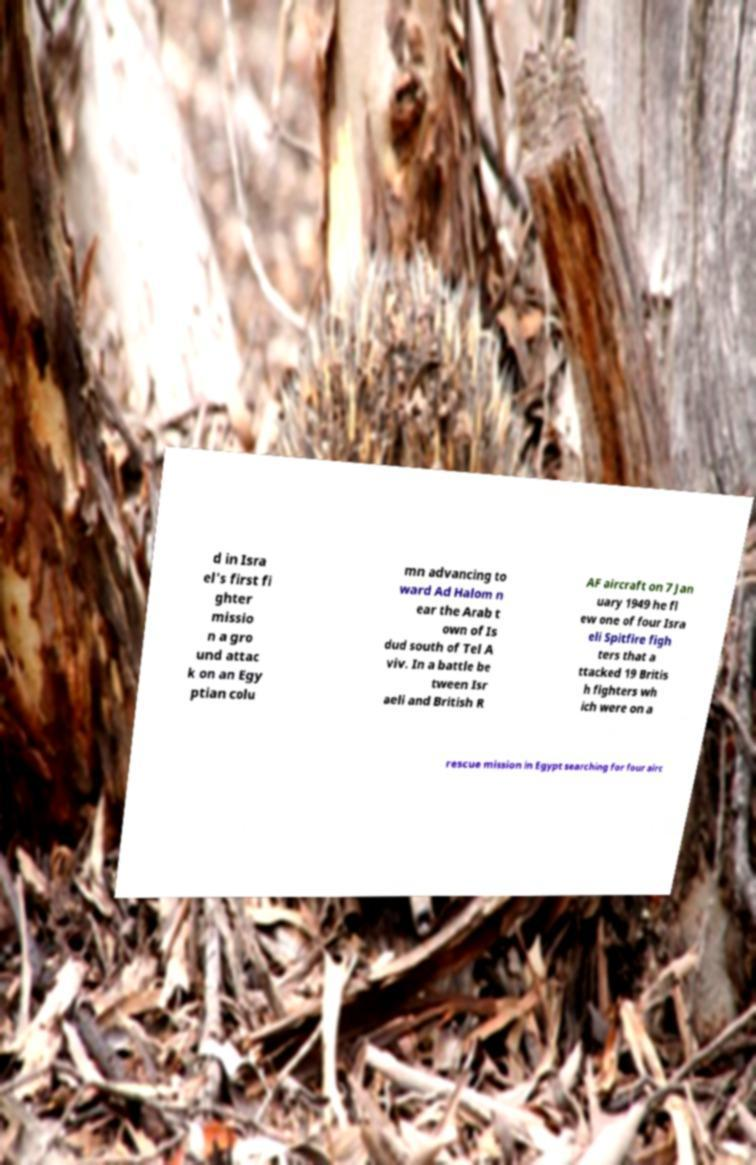Please identify and transcribe the text found in this image. d in Isra el's first fi ghter missio n a gro und attac k on an Egy ptian colu mn advancing to ward Ad Halom n ear the Arab t own of Is dud south of Tel A viv. In a battle be tween Isr aeli and British R AF aircraft on 7 Jan uary 1949 he fl ew one of four Isra eli Spitfire figh ters that a ttacked 19 Britis h fighters wh ich were on a rescue mission in Egypt searching for four airc 